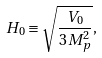<formula> <loc_0><loc_0><loc_500><loc_500>H _ { 0 } \equiv \sqrt { \frac { V _ { 0 } } { 3 M _ { p } ^ { 2 } } } ,</formula> 